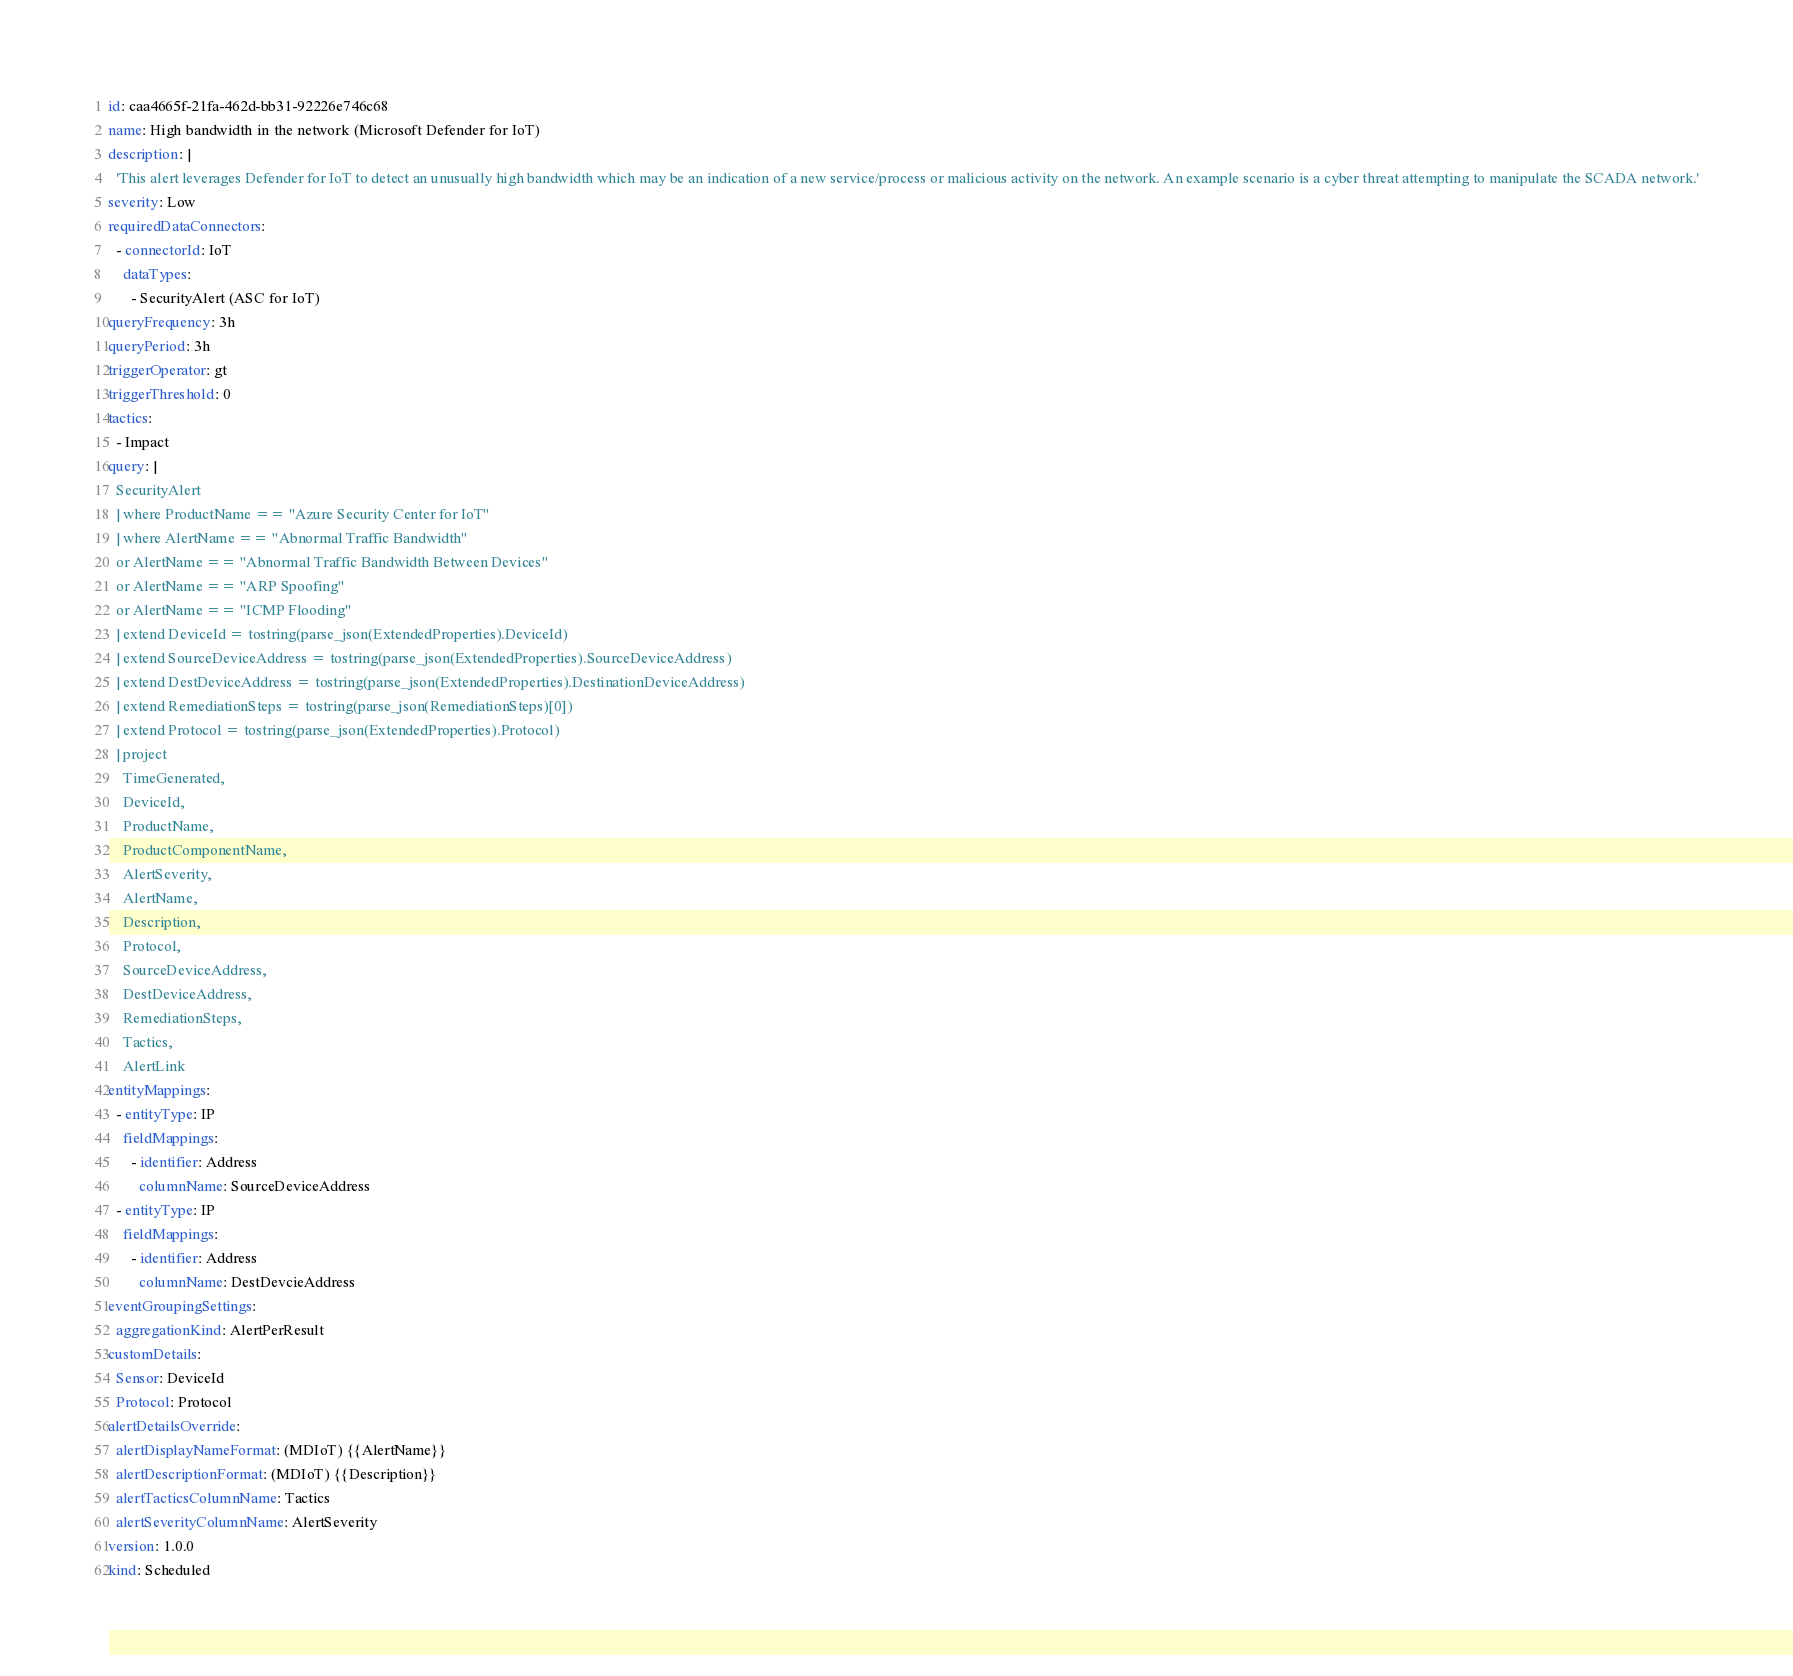Convert code to text. <code><loc_0><loc_0><loc_500><loc_500><_YAML_>id: caa4665f-21fa-462d-bb31-92226e746c68
name: High bandwidth in the network (Microsoft Defender for IoT)
description: |
  'This alert leverages Defender for IoT to detect an unusually high bandwidth which may be an indication of a new service/process or malicious activity on the network. An example scenario is a cyber threat attempting to manipulate the SCADA network.'
severity: Low
requiredDataConnectors:
  - connectorId: IoT
    dataTypes:
      - SecurityAlert (ASC for IoT)
queryFrequency: 3h
queryPeriod: 3h
triggerOperator: gt
triggerThreshold: 0
tactics:
  - Impact
query: |
  SecurityAlert
  | where ProductName == "Azure Security Center for IoT"
  | where AlertName == "Abnormal Traffic Bandwidth" 
  or AlertName == "Abnormal Traffic Bandwidth Between Devices" 
  or AlertName == "ARP Spoofing" 
  or AlertName == "ICMP Flooding"
  | extend DeviceId = tostring(parse_json(ExtendedProperties).DeviceId)
  | extend SourceDeviceAddress = tostring(parse_json(ExtendedProperties).SourceDeviceAddress)
  | extend DestDeviceAddress = tostring(parse_json(ExtendedProperties).DestinationDeviceAddress)
  | extend RemediationSteps = tostring(parse_json(RemediationSteps)[0])
  | extend Protocol = tostring(parse_json(ExtendedProperties).Protocol)
  | project
    TimeGenerated,
    DeviceId,
    ProductName,
    ProductComponentName,
    AlertSeverity,
    AlertName,
    Description,
    Protocol,
    SourceDeviceAddress,
    DestDeviceAddress,
    RemediationSteps,
    Tactics,
    AlertLink
entityMappings:
  - entityType: IP
    fieldMappings:
      - identifier: Address
        columnName: SourceDeviceAddress
  - entityType: IP
    fieldMappings:
      - identifier: Address
        columnName: DestDevcieAddress
eventGroupingSettings:
  aggregationKind: AlertPerResult
customDetails:
  Sensor: DeviceId
  Protocol: Protocol
alertDetailsOverride:
  alertDisplayNameFormat: (MDIoT) {{AlertName}}
  alertDescriptionFormat: (MDIoT) {{Description}}
  alertTacticsColumnName: Tactics
  alertSeverityColumnName: AlertSeverity
version: 1.0.0
kind: Scheduled
</code> 